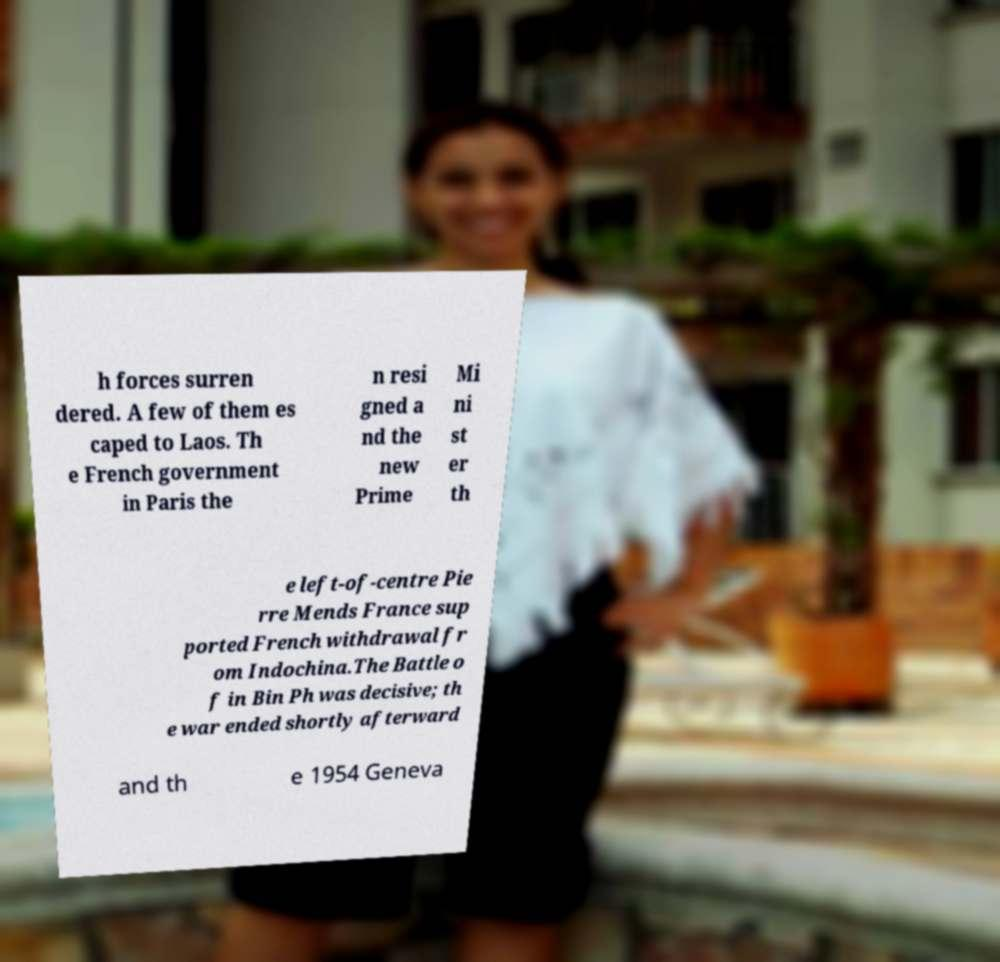There's text embedded in this image that I need extracted. Can you transcribe it verbatim? h forces surren dered. A few of them es caped to Laos. Th e French government in Paris the n resi gned a nd the new Prime Mi ni st er th e left-of-centre Pie rre Mends France sup ported French withdrawal fr om Indochina.The Battle o f in Bin Ph was decisive; th e war ended shortly afterward and th e 1954 Geneva 